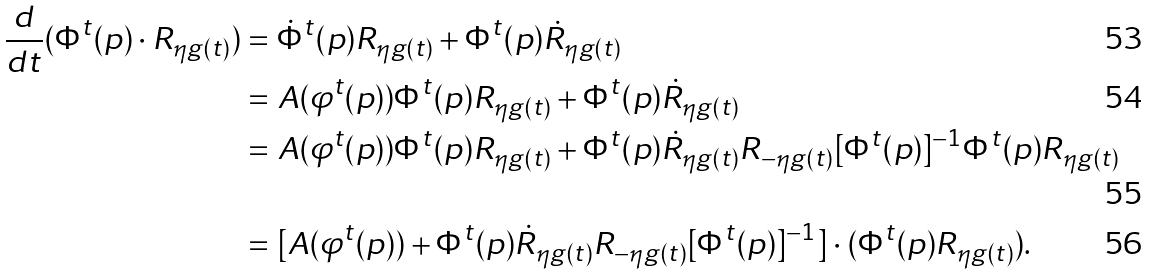Convert formula to latex. <formula><loc_0><loc_0><loc_500><loc_500>\frac { d } { d t } ( \Phi ^ { t } ( p ) \cdot { R } _ { \eta { g ( t ) } } ) & = \dot { \Phi } ^ { t } ( p ) R _ { \eta { g ( t ) } } + \Phi ^ { t } ( p ) \dot { R } _ { \eta { g ( t ) } } \\ & = A ( \varphi ^ { t } ( p ) ) \Phi ^ { t } ( p ) R _ { \eta { g ( t ) } } + \Phi ^ { t } ( p ) \dot { R } _ { \eta { g ( t ) } } \\ & = A ( \varphi ^ { t } ( p ) ) \Phi ^ { t } ( p ) R _ { \eta { g ( t ) } } + \Phi ^ { t } ( p ) \dot { R } _ { \eta { g ( t ) } } R _ { - \eta { g ( t ) } } [ \Phi ^ { t } ( p ) ] ^ { - 1 } \Phi ^ { t } ( p ) R _ { \eta { g ( t ) } } \\ & = [ A ( \varphi ^ { t } ( p ) ) + \Phi ^ { t } ( p ) \dot { R } _ { \eta { g ( t ) } } R _ { - \eta { g ( t ) } } [ \Phi ^ { t } ( p ) ] ^ { - 1 } ] \cdot ( \Phi ^ { t } ( p ) R _ { \eta { g ( t ) } } ) .</formula> 